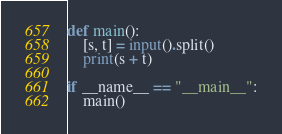Convert code to text. <code><loc_0><loc_0><loc_500><loc_500><_Python_>def main():
    [s, t] = input().split()
    print(s + t)

if __name__ == "__main__":
	main()</code> 